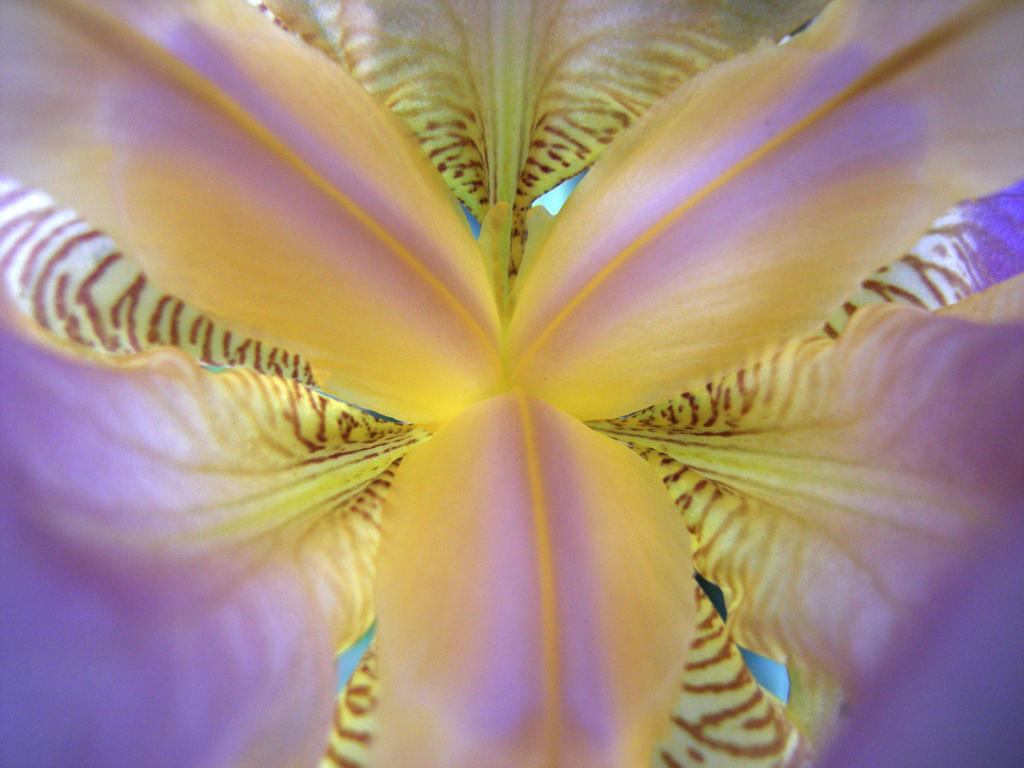What is the main subject of the image? There is a flower in the image. Can you describe the color of the flower? The flower is yellow and purple in color. What type of record is being played in the background of the image? There is no record or any indication of sound in the image; it only features a flower. 